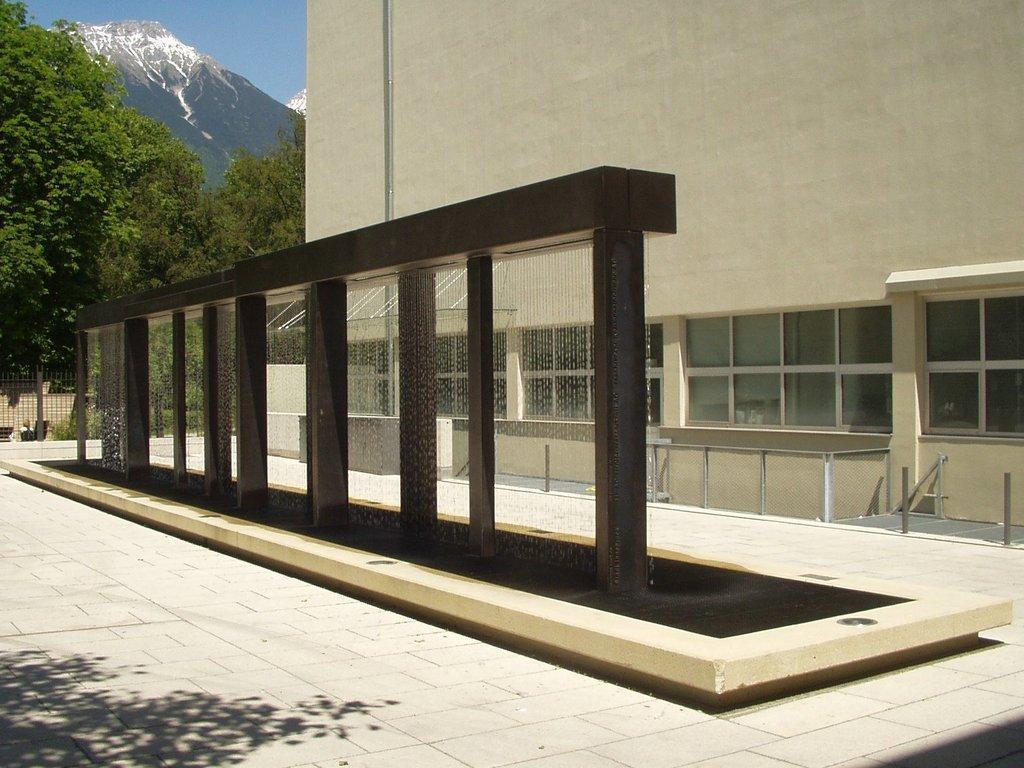How would you summarize this image in a sentence or two? In this picture I can see building, trees and I can see a hill in the black and a blue sky. 